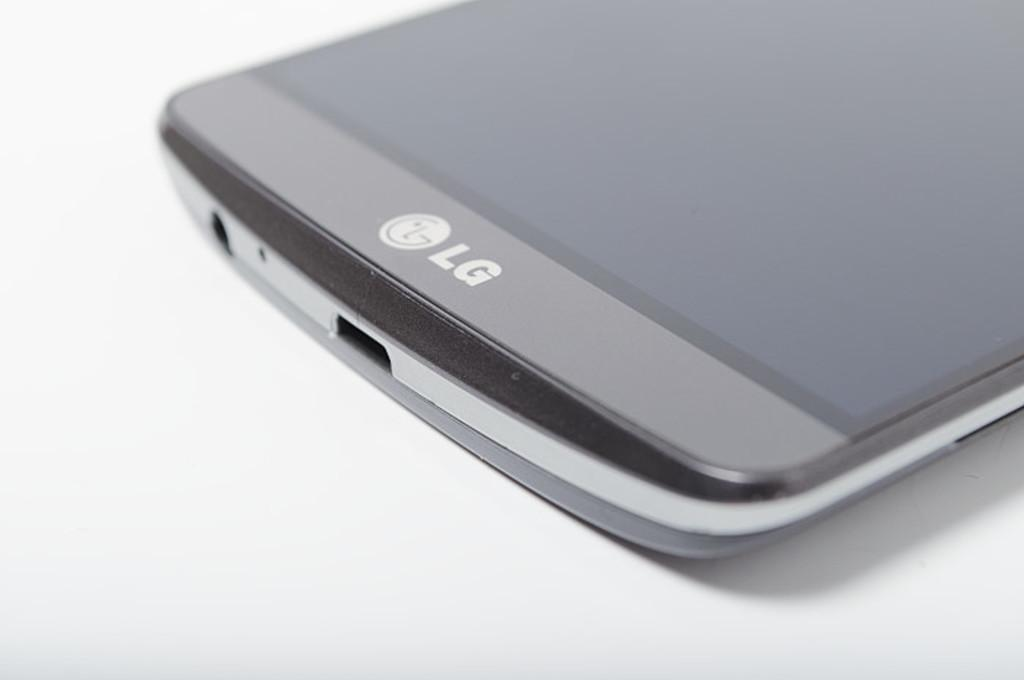<image>
Write a terse but informative summary of the picture. A grey LG phone lays on a white surface, only the bottom half visible. 